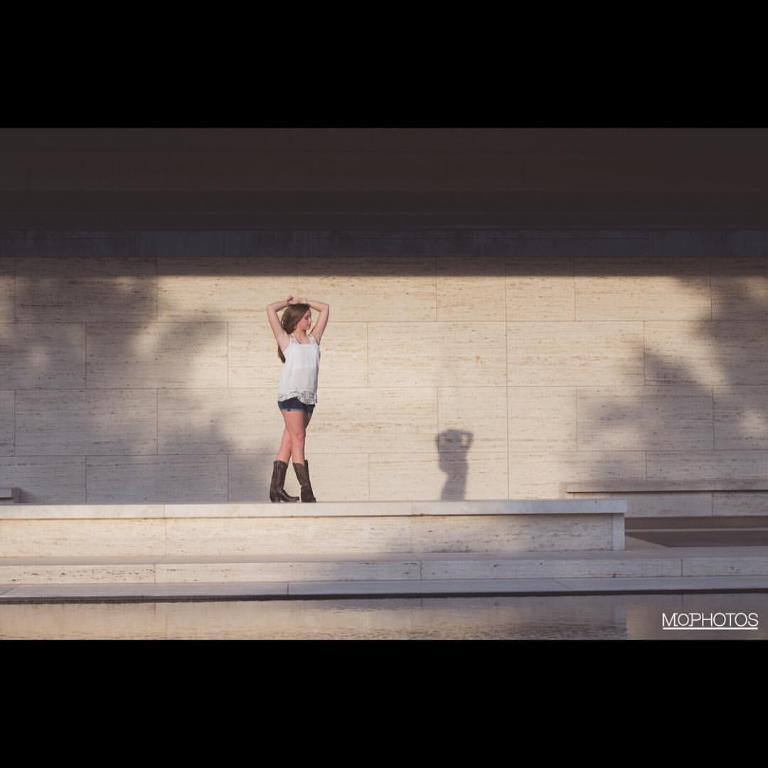What can be seen in the image that people walk on? There is a path in the image that people can walk on. What is the woman in the image doing? The woman is standing and giving a pose in the image. What color is the top that the woman is wearing? The woman is wearing a white top. What is the color of the wall in the image? The wall in the image is cream in color. Can you hear the woman's voice in the image? There is no sound or audio in the image, so it is not possible to hear the woman's voice. What type of pail is being used by the woman in the image? There is no pail present in the image; the woman is giving a pose and wearing a white top. 